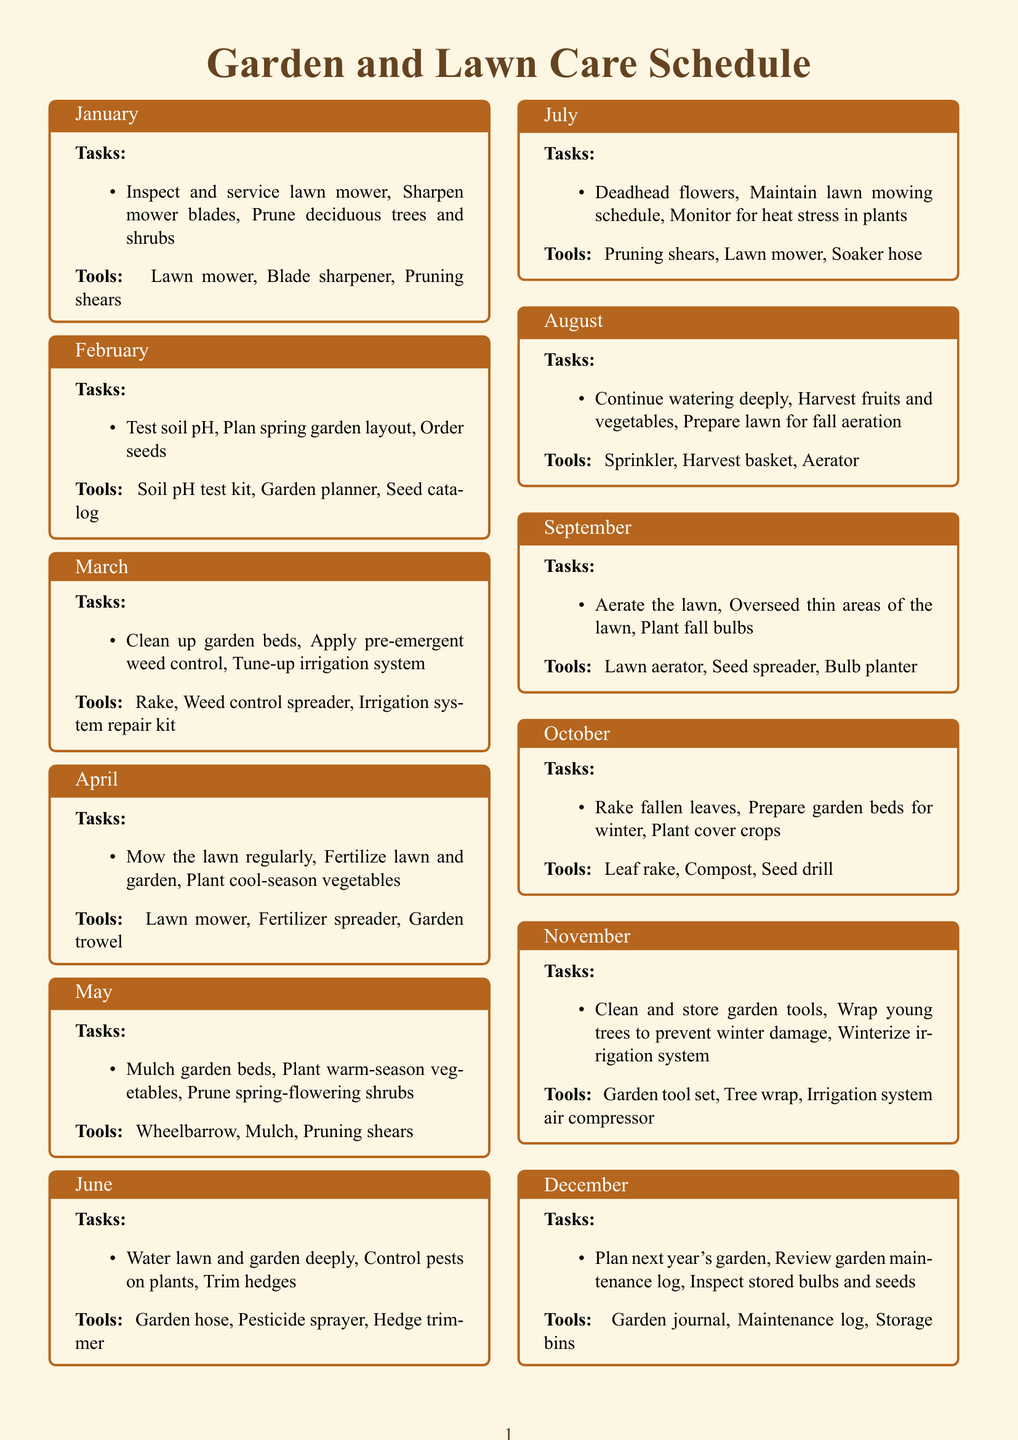What are the tasks for May? The tasks for May include mulching garden beds, planting warm-season vegetables, and pruning spring-flowering shrubs.
Answer: Mulch garden beds, Plant warm-season vegetables, Prune spring-flowering shrubs What tool is needed for raking fallen leaves? Raking fallen leaves requires a specific tool mentioned in the October section of the document.
Answer: Leaf rake How many tasks are listed for the month of June? The month of June contains three specific tasks related to garden and lawn care.
Answer: 3 What type of plants should be monitored in July? The tasks for July include monitoring for heat stress in certain types of plants, as described in that month's entry.
Answer: Plants Which month involves preparing garden beds for winter? The document specifies October for preparing garden beds for the winter season.
Answer: October What is the main focus in November's maintenance tasks? The main focus in November's tasks relates to cleaning and storing tools, as well as winterizing systems.
Answer: Clean and store garden tools What is required to aerate the lawn in September? To aerate the lawn, a specific tool is mentioned that is relevant to that process in the September section.
Answer: Lawn aerator Which month suggests planting fall bulbs? Planting fall bulbs is specifically mentioned as a task in the September section.
Answer: September 